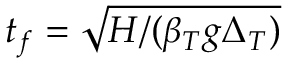Convert formula to latex. <formula><loc_0><loc_0><loc_500><loc_500>t _ { f } = \sqrt { H / ( \beta _ { T } g \Delta _ { T } ) }</formula> 